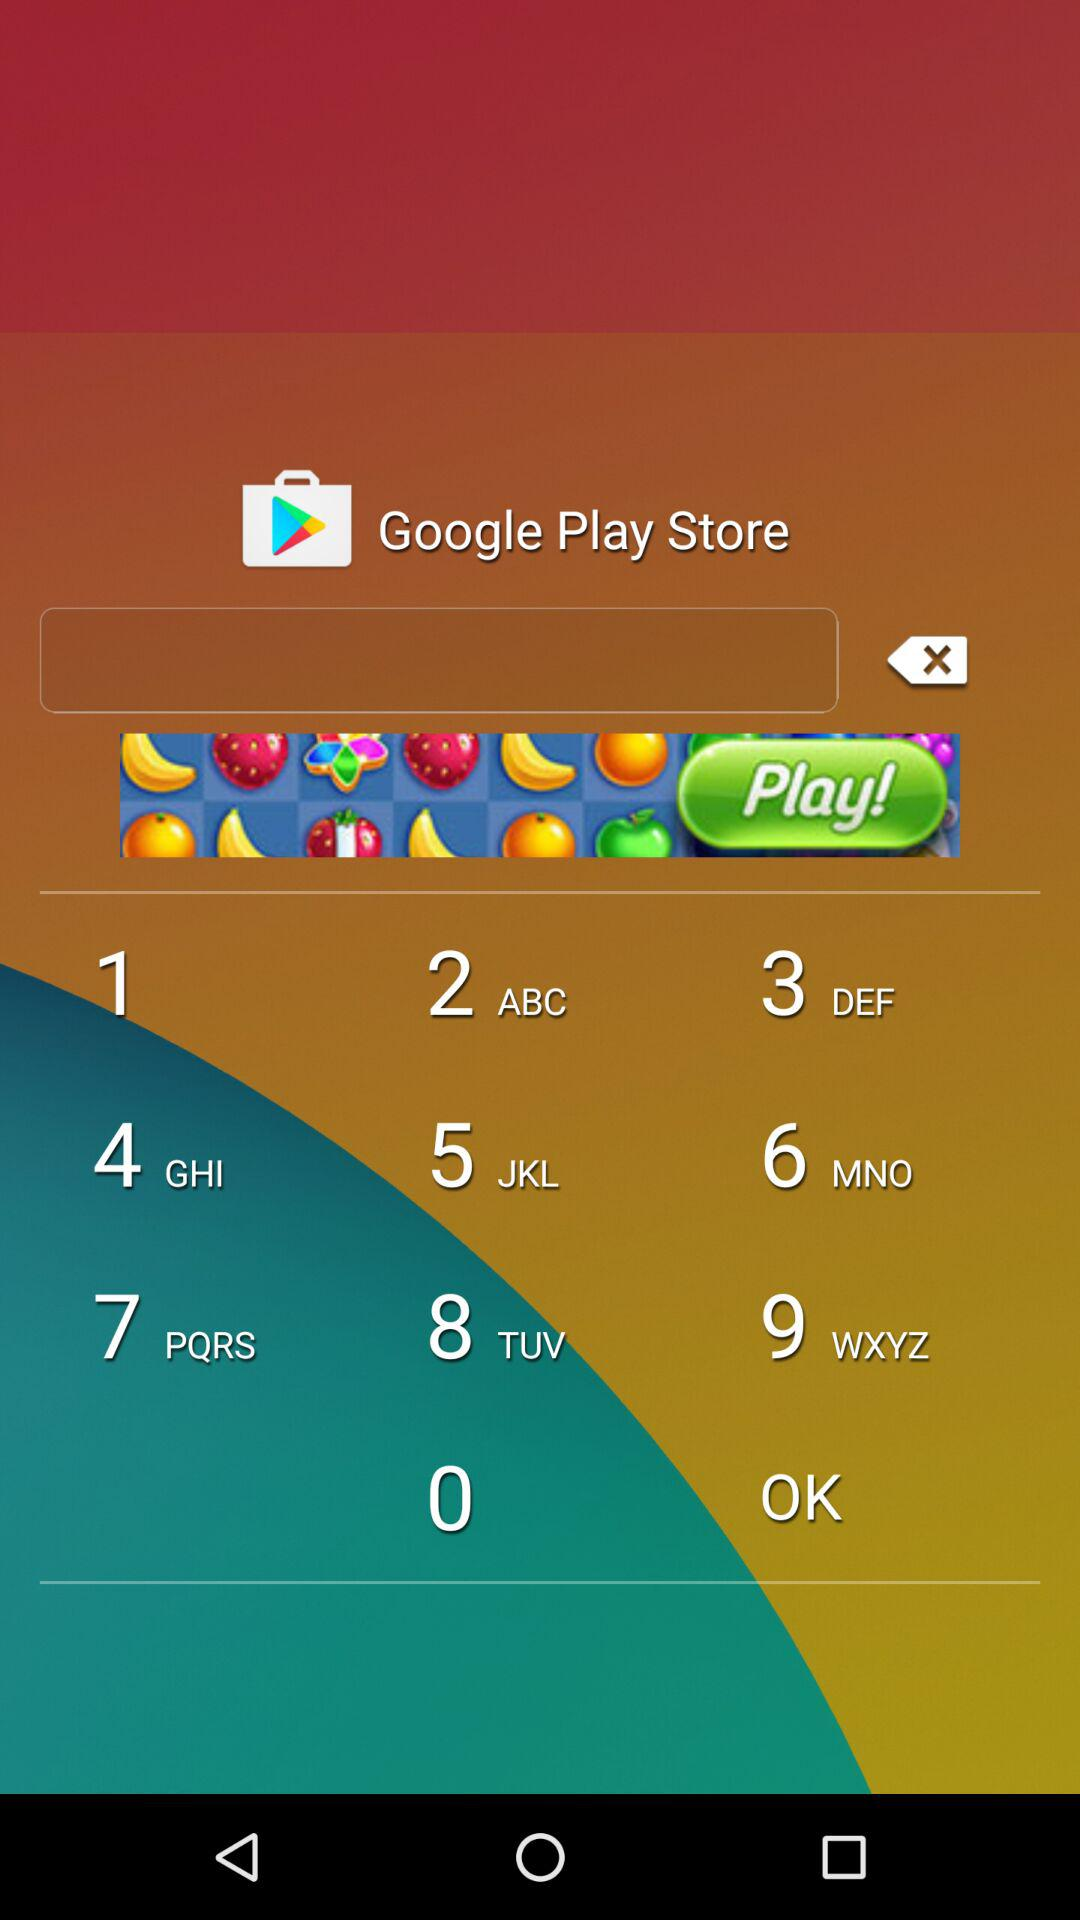What is the date range mentioned for the NT ultrasound? The mentioned date range for the NT ultrasound is from June 4, 2017 to June 25, 2017. 